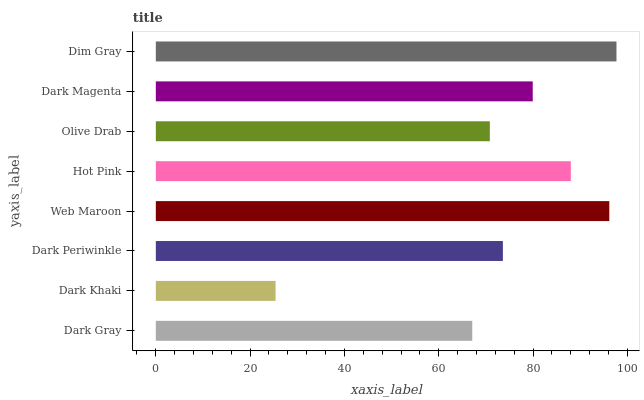Is Dark Khaki the minimum?
Answer yes or no. Yes. Is Dim Gray the maximum?
Answer yes or no. Yes. Is Dark Periwinkle the minimum?
Answer yes or no. No. Is Dark Periwinkle the maximum?
Answer yes or no. No. Is Dark Periwinkle greater than Dark Khaki?
Answer yes or no. Yes. Is Dark Khaki less than Dark Periwinkle?
Answer yes or no. Yes. Is Dark Khaki greater than Dark Periwinkle?
Answer yes or no. No. Is Dark Periwinkle less than Dark Khaki?
Answer yes or no. No. Is Dark Magenta the high median?
Answer yes or no. Yes. Is Dark Periwinkle the low median?
Answer yes or no. Yes. Is Olive Drab the high median?
Answer yes or no. No. Is Web Maroon the low median?
Answer yes or no. No. 